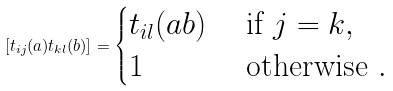Convert formula to latex. <formula><loc_0><loc_0><loc_500><loc_500>[ t _ { i j } ( a ) t _ { k l } ( b ) ] = \begin{cases} t _ { i l } ( a b ) & \text { if } j = k , \\ 1 & \text { otherwise } . \end{cases}</formula> 